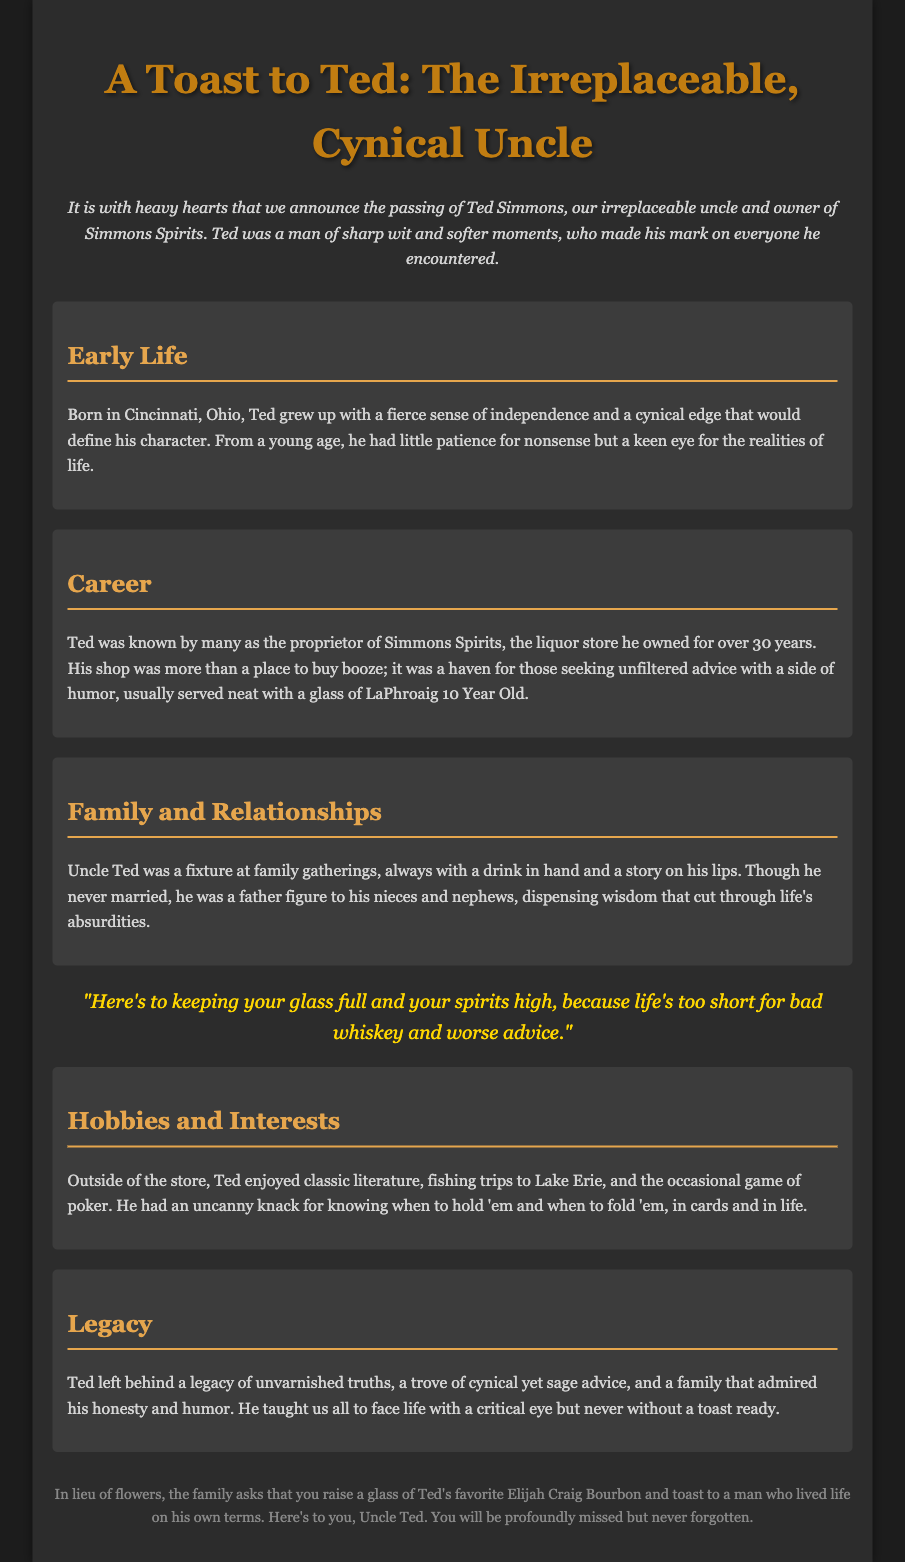What was Ted's full name? The document mentions his full name as Ted Simmons.
Answer: Ted Simmons Where was Ted born? The document states that Ted was born in Cincinnati, Ohio.
Answer: Cincinnati, Ohio How long did Ted own Simmons Spirits? The document indicates that Ted owned the liquor store for over 30 years.
Answer: over 30 years What was Ted's favorite whiskey? The document specifies that Ted's favorite whiskey was Elijah Craig Bourbon.
Answer: Elijah Craig Bourbon What is one of Ted's hobbies? The document lists fishing trips to Lake Erie as one of his hobbies.
Answer: fishing trips to Lake Erie What type of advice did Ted provide? The document describes Ted's advice as unfiltered and cynical yet sage.
Answer: unfiltered and cynical yet sage What quote encapsulates Ted's philosophy? The document contains a quote reflecting his philosophy about life and whiskey.
Answer: "Here's to keeping your glass full and your spirits high, because life's too short for bad whiskey and worse advice." What does the family ask for in lieu of flowers? The document states that the family asks to raise a glass of Ted's favorite bourbon.
Answer: raise a glass of Ted's favorite bourbon 